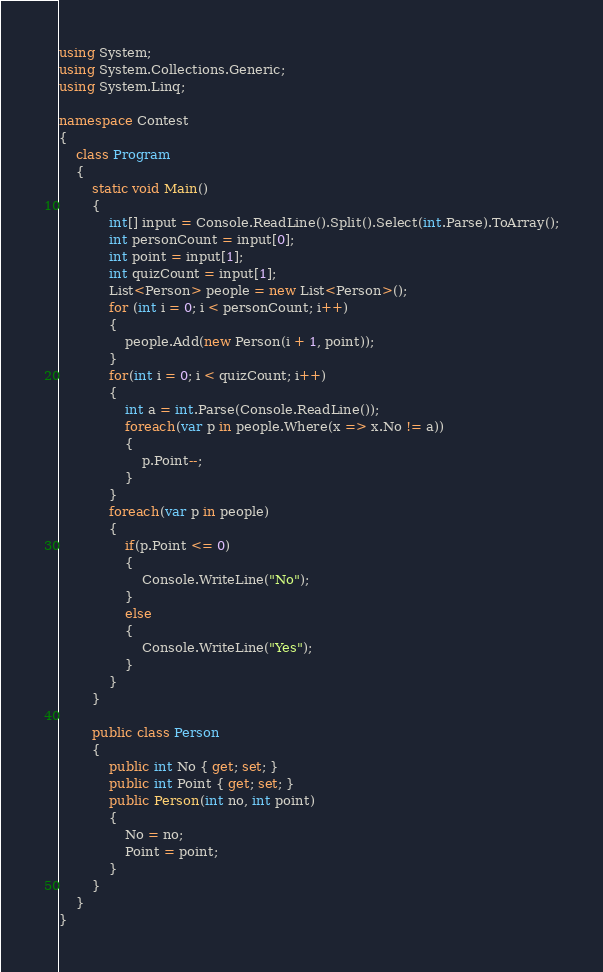Convert code to text. <code><loc_0><loc_0><loc_500><loc_500><_C#_>using System;
using System.Collections.Generic;
using System.Linq;

namespace Contest
{
    class Program
    {
        static void Main()
        {
            int[] input = Console.ReadLine().Split().Select(int.Parse).ToArray();
            int personCount = input[0];
            int point = input[1];
            int quizCount = input[1];
            List<Person> people = new List<Person>();
            for (int i = 0; i < personCount; i++)
            {
                people.Add(new Person(i + 1, point));
            }
            for(int i = 0; i < quizCount; i++)
            {
                int a = int.Parse(Console.ReadLine());
                foreach(var p in people.Where(x => x.No != a))
                {
                    p.Point--;
                }
            }
            foreach(var p in people)
            {
                if(p.Point <= 0)
                {
                    Console.WriteLine("No");
                }
                else
                {
                    Console.WriteLine("Yes");
                }
            }
        }

        public class Person
        {
            public int No { get; set; }
            public int Point { get; set; }
            public Person(int no, int point)
            {
                No = no;
                Point = point;
            }
        }
    }
}
</code> 